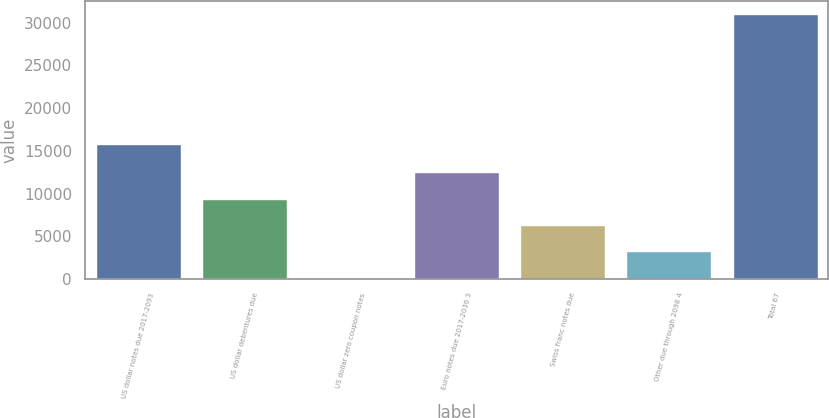<chart> <loc_0><loc_0><loc_500><loc_500><bar_chart><fcel>US dollar notes due 2017-2093<fcel>US dollar debentures due<fcel>US dollar zero coupon notes<fcel>Euro notes due 2017-2036 3<fcel>Swiss franc notes due<fcel>Other due through 2098 4<fcel>Total 67<nl><fcel>15853<fcel>9399.7<fcel>148<fcel>12483.6<fcel>6315.8<fcel>3231.9<fcel>30987<nl></chart> 